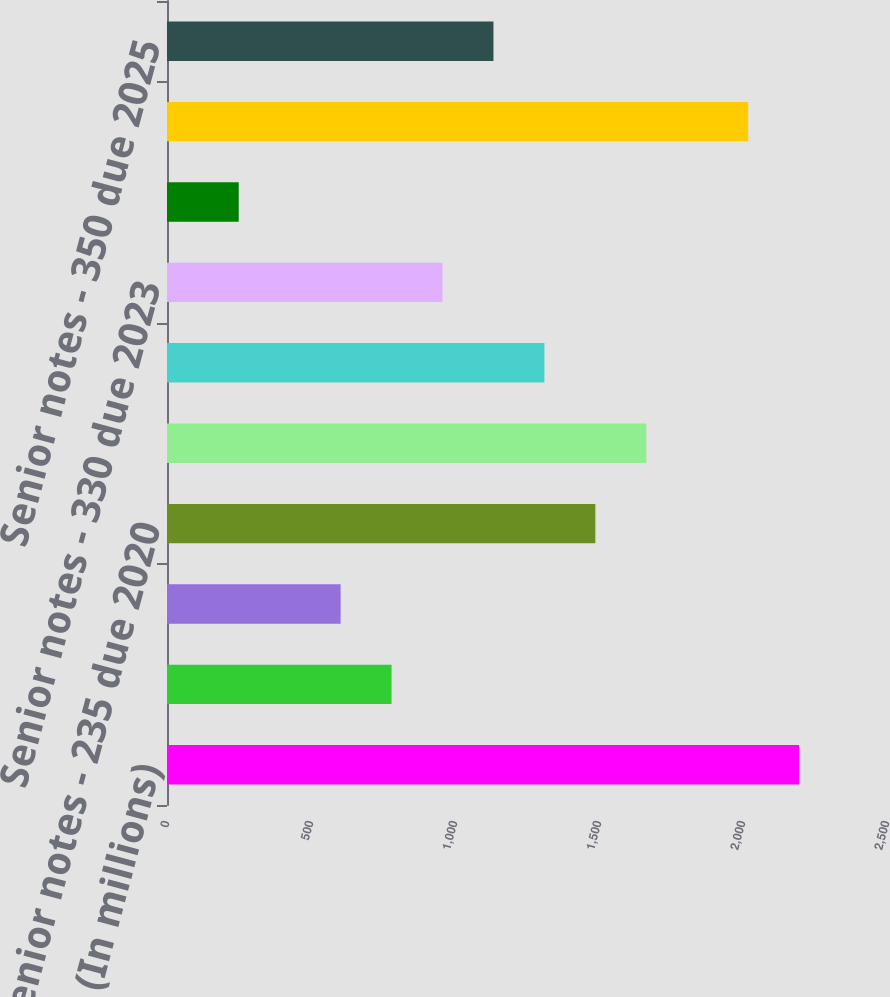<chart> <loc_0><loc_0><loc_500><loc_500><bar_chart><fcel>December 31 (In millions)<fcel>Current portion of long-term<fcel>Senior notes - 235 due 2019<fcel>Senior notes - 235 due 2020<fcel>Senior notes - 480 due 2021<fcel>Senior notes - 275 due 2022<fcel>Senior notes - 330 due 2023<fcel>Senior notes - 405 due 2023<fcel>Senior notes - 350 due 2024<fcel>Senior notes - 350 due 2025<nl><fcel>2194.9<fcel>779.7<fcel>602.8<fcel>1487.3<fcel>1664.2<fcel>1310.4<fcel>956.6<fcel>249<fcel>2018<fcel>1133.5<nl></chart> 